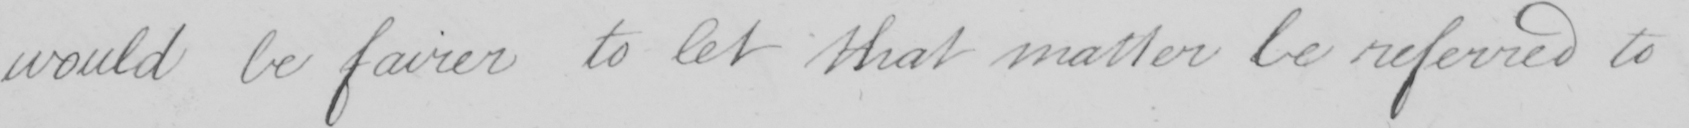What text is written in this handwritten line? would be fairer to let that matter be referred to 